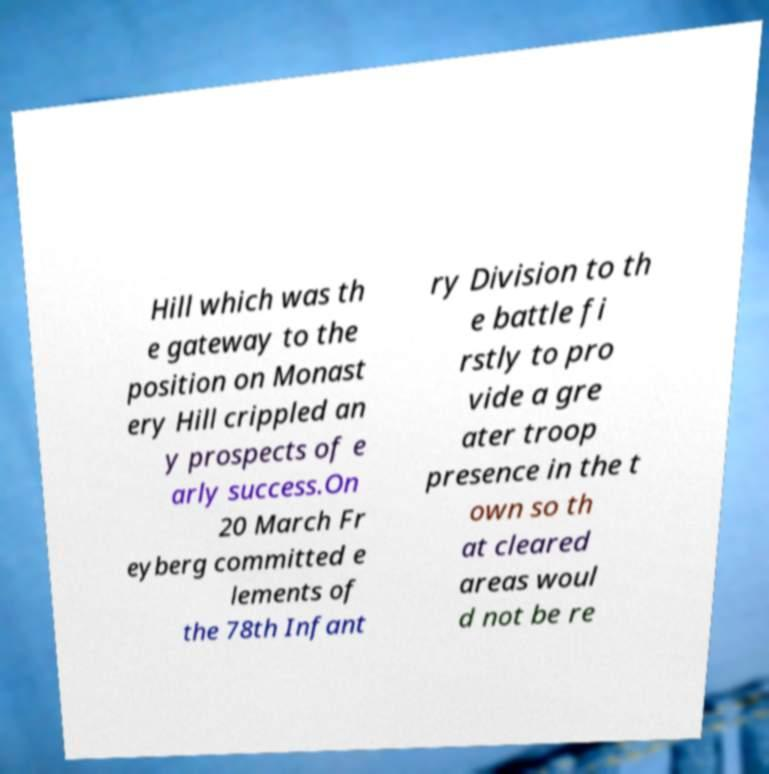What messages or text are displayed in this image? I need them in a readable, typed format. Hill which was th e gateway to the position on Monast ery Hill crippled an y prospects of e arly success.On 20 March Fr eyberg committed e lements of the 78th Infant ry Division to th e battle fi rstly to pro vide a gre ater troop presence in the t own so th at cleared areas woul d not be re 